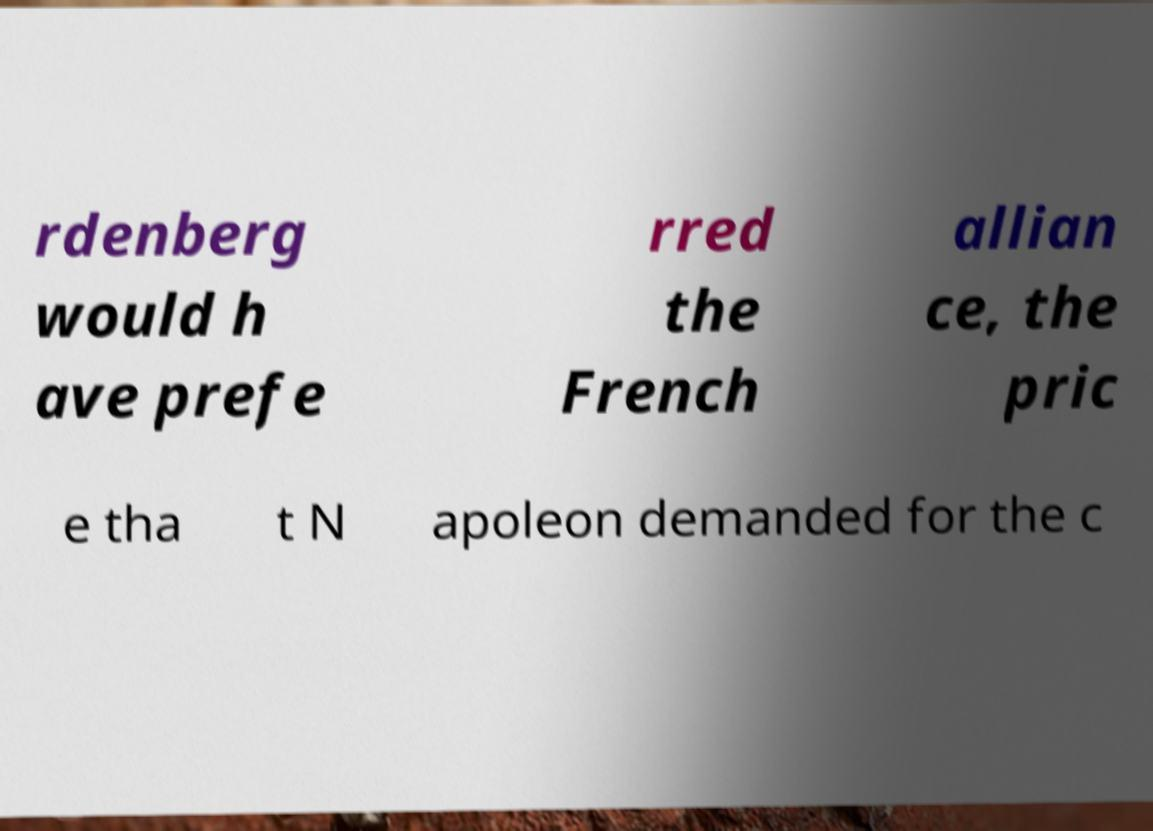For documentation purposes, I need the text within this image transcribed. Could you provide that? rdenberg would h ave prefe rred the French allian ce, the pric e tha t N apoleon demanded for the c 